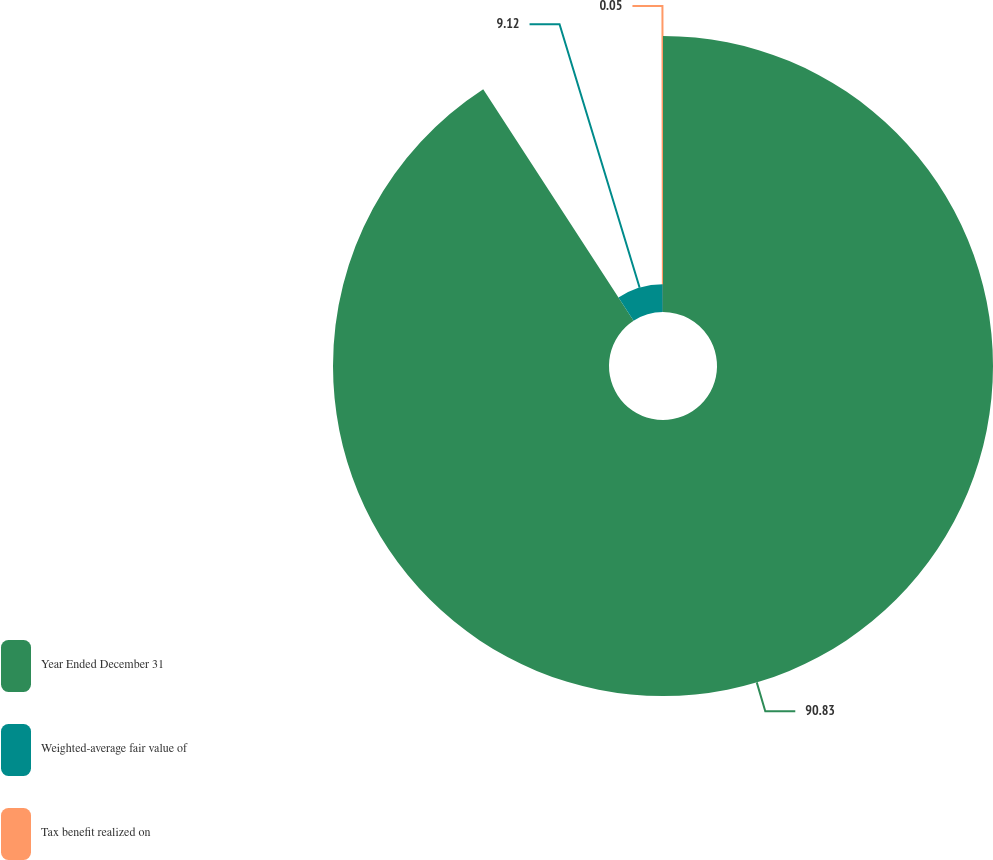Convert chart. <chart><loc_0><loc_0><loc_500><loc_500><pie_chart><fcel>Year Ended December 31<fcel>Weighted-average fair value of<fcel>Tax benefit realized on<nl><fcel>90.83%<fcel>9.12%<fcel>0.05%<nl></chart> 